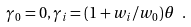<formula> <loc_0><loc_0><loc_500><loc_500>\gamma _ { 0 } = 0 , \gamma _ { i } = ( 1 + w _ { i } / w _ { 0 } ) \theta \ .</formula> 